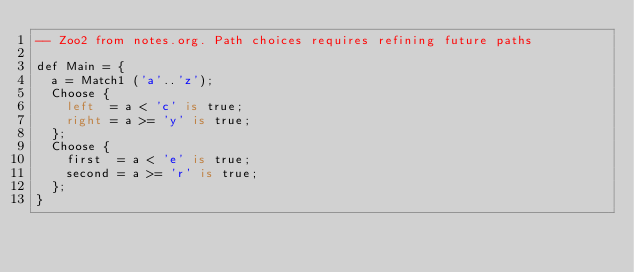Convert code to text. <code><loc_0><loc_0><loc_500><loc_500><_SQL_>-- Zoo2 from notes.org. Path choices requires refining future paths

def Main = {
  a = Match1 ('a'..'z');
  Choose {
    left  = a < 'c' is true;
    right = a >= 'y' is true;
  };
  Choose {
    first  = a < 'e' is true;
    second = a >= 'r' is true; 
  };
}
</code> 